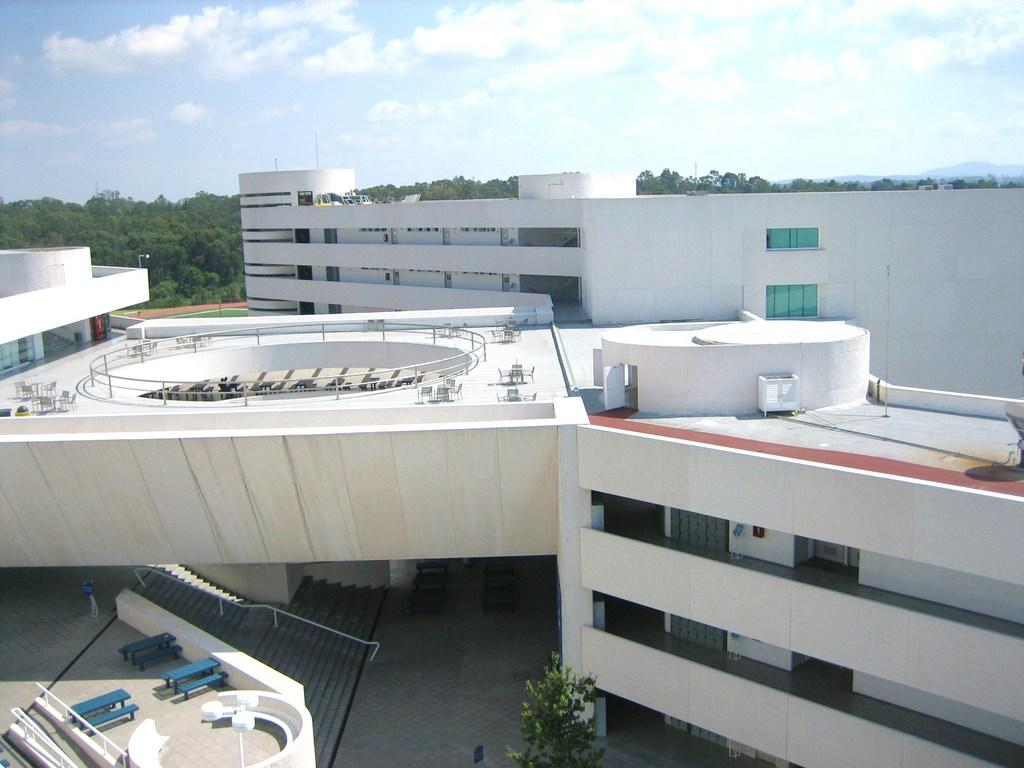What type of structures are visible in the image? There are buildings with windows in the image. What type of seating can be seen in the image? There are benches in the image. What type of vegetation is present in the image? There are trees in the image. What type of vertical structure can be seen in the image? There is a pole in the image. What is visible in the sky in the image? The sky is visible in the image and appears cloudy. How many spiders are crawling on the buildings in the image? There are no spiders visible in the image; it features buildings, benches, trees, a pole, and a cloudy sky. Can you describe the man walking on the beach in the image? There is no man or beach present in the image. 